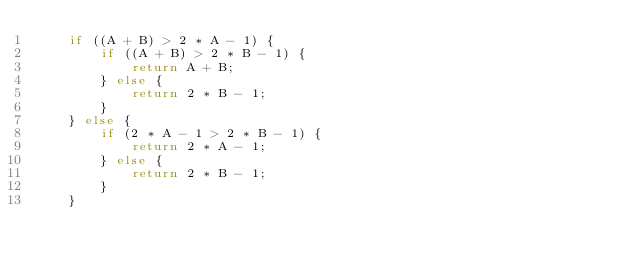<code> <loc_0><loc_0><loc_500><loc_500><_C_>    if ((A + B) > 2 * A - 1) {
        if ((A + B) > 2 * B - 1) {
            return A + B;
        } else {
            return 2 * B - 1;
        }
    } else {
        if (2 * A - 1 > 2 * B - 1) {
            return 2 * A - 1;
        } else {
            return 2 * B - 1;
        }
    }</code> 